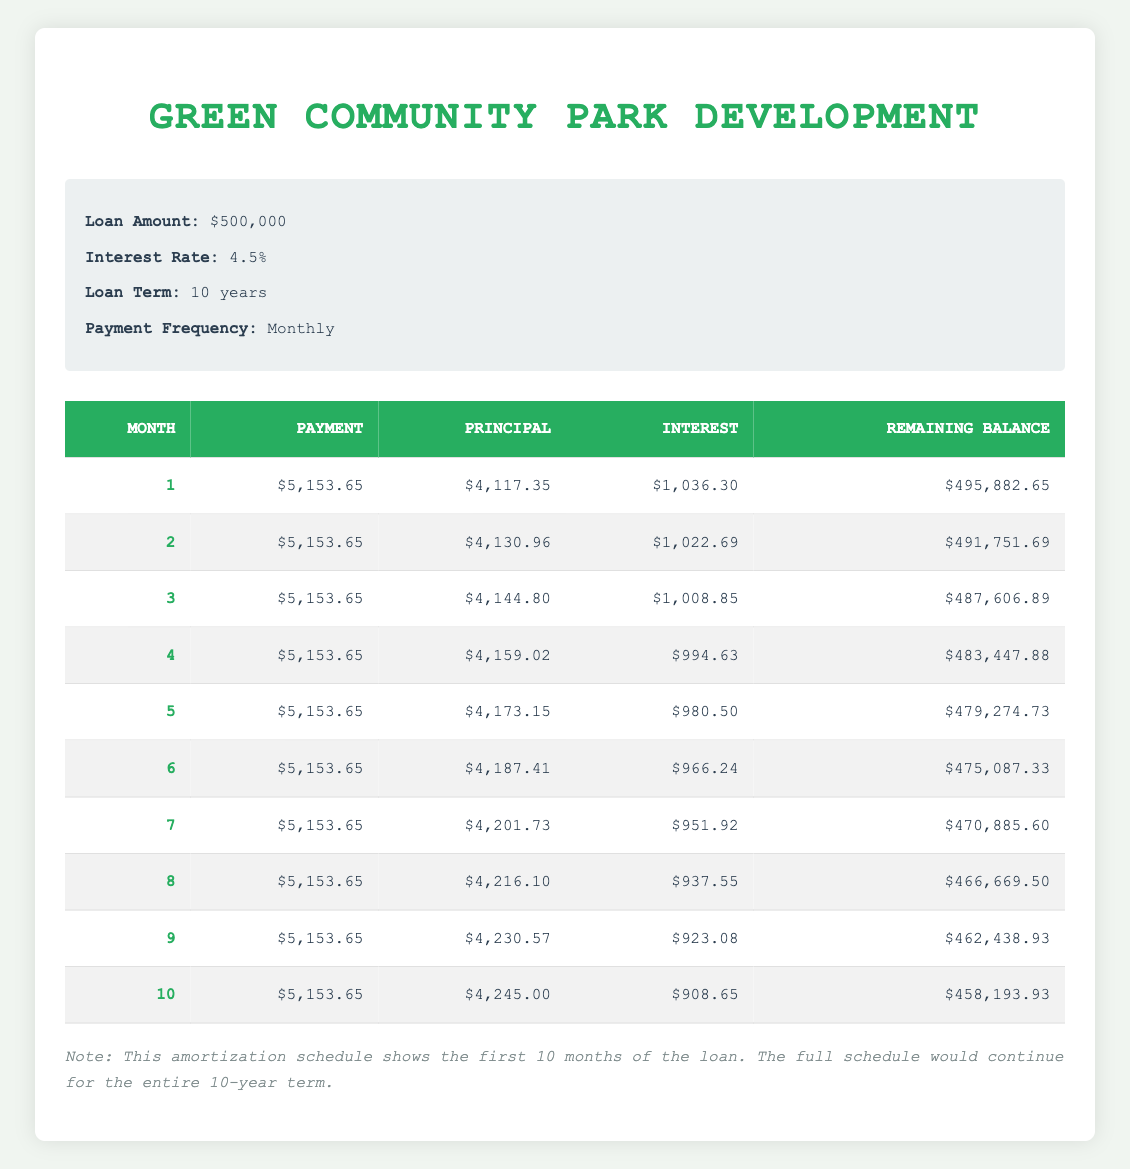What is the total payment made in the first month? The first month's total payment is listed in the table under the "Payment" column for month 1, which shows an amount of $5,153.65.
Answer: 5,153.65 What is the principal amount paid in the second month? The principal amount for the second month can be found in the "Principal" column for month 2, which is $4,130.96.
Answer: 4,130.96 Is the interest payment in the third month higher than in the first month? By comparing the "Interest" column for month 1 ($1,036.30) and month 3 ($1,008.85), month 3 has a lower interest payment. Therefore, it is false that month 3 is higher than month 1.
Answer: No What is the remaining balance after the fifth month? The remaining balance can be found in the "Remaining Balance" column for month 5, which shows $479,274.73.
Answer: 479,274.73 Calculate the average principal payment over the first five months. Adding the principal payments from months 1 to 5 gives us $4,117.35 + $4,130.96 + $4,144.80 + $4,159.02 + $4,173.15 = $20,725.28. Dividing this by 5 (the number of months), the average principal payment is $20,725.28 / 5 = $4,145.06.
Answer: 4,145.06 What is the total interest paid in the first 10 months? Summing the interest payments from each month, we find: $1,036.30 + $1,022.69 + $1,008.85 + $994.63 + $980.50 + $966.24 + $951.92 + $937.55 + $923.08 + $908.65 = $9,828.77.
Answer: 9,828.77 Does the principal payment increase every month for the first ten months? By examining the "Principal" column from month 1 to month 10, we see that each month's principal payment is higher than the previous month, confirming that the principal payment does indeed increase every month.
Answer: Yes What is the change in remaining balance from the first month to the second month? The remaining balance at the end of the first month is $495,882.65, and at the end of the second month, it is $491,751.69. The change is calculated by subtracting the second month's balance from the first month's balance: $495,882.65 - $491,751.69 = $4,130.96.
Answer: 4,130.96 What is the highest single monthly payment in the first ten months? All monthly payments are the same at $5,153.65 for every month, as seen in the "Payment" column. Therefore, the highest payment is also the same.
Answer: 5,153.65 